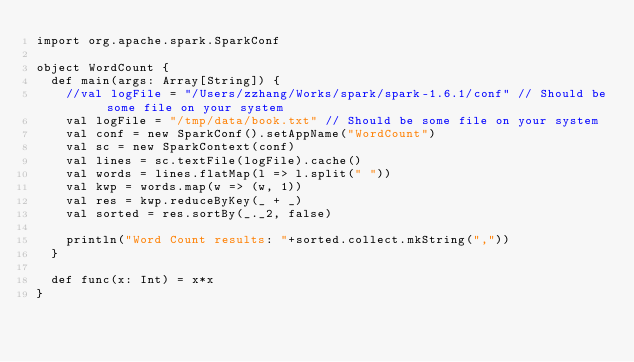<code> <loc_0><loc_0><loc_500><loc_500><_Scala_>import org.apache.spark.SparkConf

object WordCount {
  def main(args: Array[String]) {
    //val logFile = "/Users/zzhang/Works/spark/spark-1.6.1/conf" // Should be some file on your system
    val logFile = "/tmp/data/book.txt" // Should be some file on your system
    val conf = new SparkConf().setAppName("WordCount")
    val sc = new SparkContext(conf)
    val lines = sc.textFile(logFile).cache()
    val words = lines.flatMap(l => l.split(" "))
    val kwp = words.map(w => (w, 1))
    val res = kwp.reduceByKey(_ + _)
    val sorted = res.sortBy(_._2, false)

    println("Word Count results: "+sorted.collect.mkString(","))
  }

  def func(x: Int) = x*x
}
</code> 